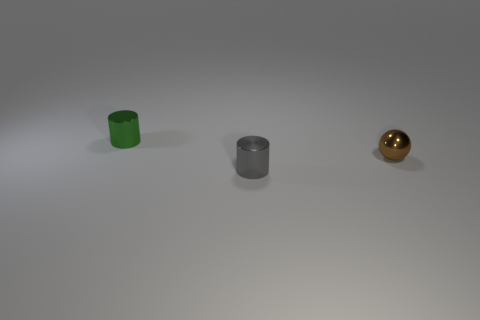How big is the object behind the brown sphere behind the small gray metal cylinder?
Offer a very short reply. Small. There is a small cylinder in front of the small brown metallic ball; what is it made of?
Provide a short and direct response. Metal. How many things are tiny shiny objects behind the small brown thing or cylinders that are behind the sphere?
Offer a terse response. 1. What material is the gray thing that is the same shape as the green thing?
Provide a short and direct response. Metal. There is a thing to the left of the small gray metal thing; is its color the same as the tiny cylinder in front of the tiny green metallic cylinder?
Your response must be concise. No. Is there another object of the same size as the brown thing?
Provide a succinct answer. Yes. The thing that is both behind the gray object and on the right side of the tiny green metallic cylinder is made of what material?
Ensure brevity in your answer.  Metal. What number of matte things are big cyan spheres or brown balls?
Give a very brief answer. 0. What is the shape of the brown object that is made of the same material as the green object?
Provide a short and direct response. Sphere. How many tiny shiny cylinders are left of the tiny gray metallic cylinder and in front of the sphere?
Make the answer very short. 0. 